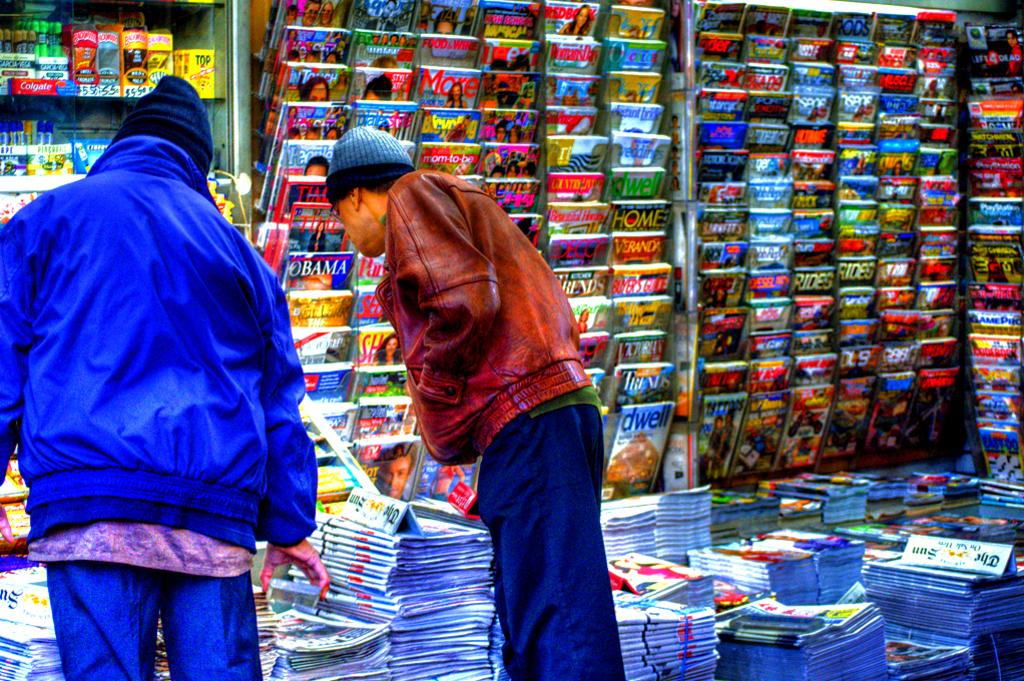<image>
Offer a succinct explanation of the picture presented. Two people browse various publications, including Time magazine and The Sun newspaper. 